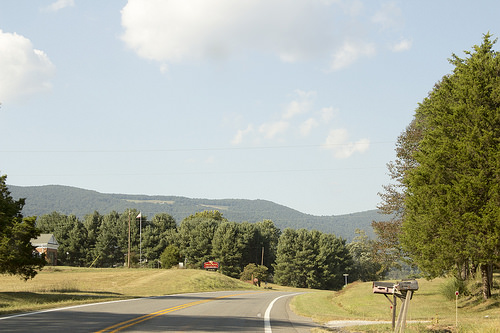<image>
Is the sky behind the tree? Yes. From this viewpoint, the sky is positioned behind the tree, with the tree partially or fully occluding the sky. 